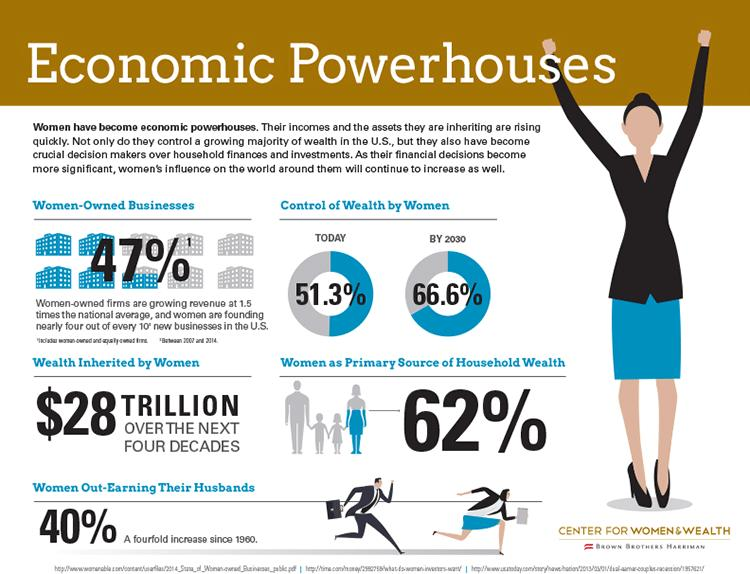Give some essential details in this illustration. By 2030, it is projected that women will control 66.6% of the wealth in the world. 